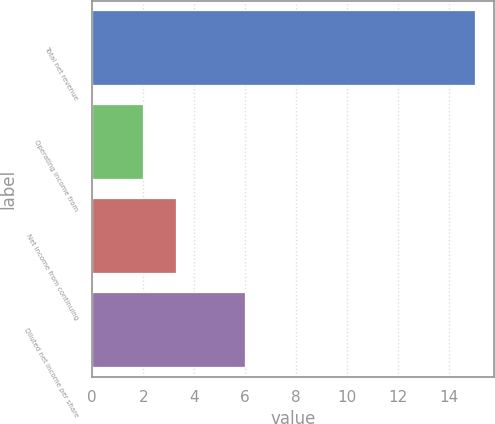Convert chart. <chart><loc_0><loc_0><loc_500><loc_500><bar_chart><fcel>Total net revenue<fcel>Operating income from<fcel>Net income from continuing<fcel>Diluted net income per share<nl><fcel>15<fcel>2<fcel>3.3<fcel>6<nl></chart> 